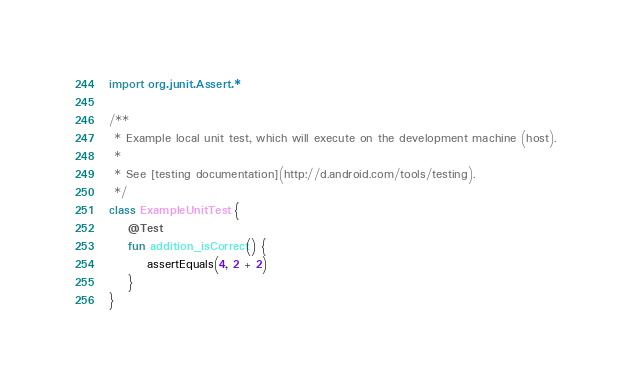Convert code to text. <code><loc_0><loc_0><loc_500><loc_500><_Kotlin_>import org.junit.Assert.*

/**
 * Example local unit test, which will execute on the development machine (host).
 *
 * See [testing documentation](http://d.android.com/tools/testing).
 */
class ExampleUnitTest {
    @Test
    fun addition_isCorrect() {
        assertEquals(4, 2 + 2)
    }
}
</code> 